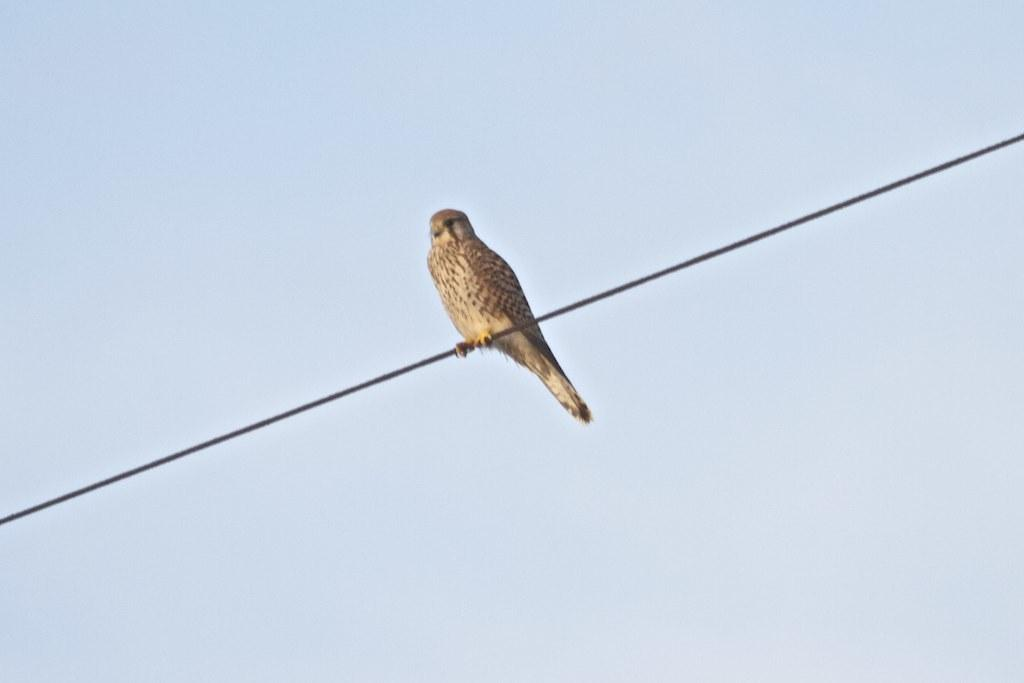What type of animal is present in the image? There is a bird in the image. What is the bird standing on? The bird is standing on a wire. What color is the background of the image? The background of the image is blue. What type of manager can be seen in the image? There is no manager present in the image; it features a bird standing on a wire with a blue background. What type of bells are hanging from the bird's neck in the image? There are no bells present in the image; it features a bird standing on a wire with a blue background. 